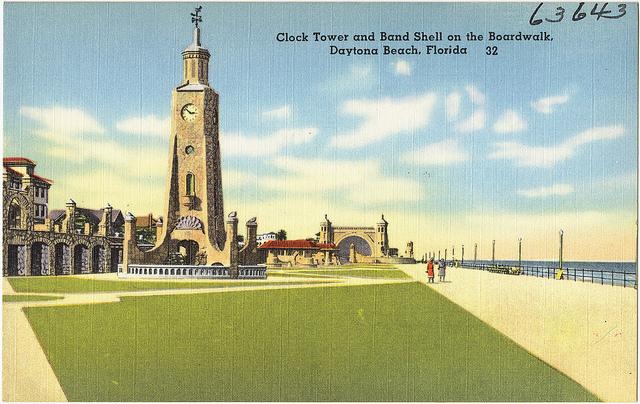What time does the Clocktower say?
Concise answer only. 2:50. What is one state that borders the state where this photo was taken?
Keep it brief. Georgia. Why would someone want to visit here?
Give a very brief answer. Historic. 